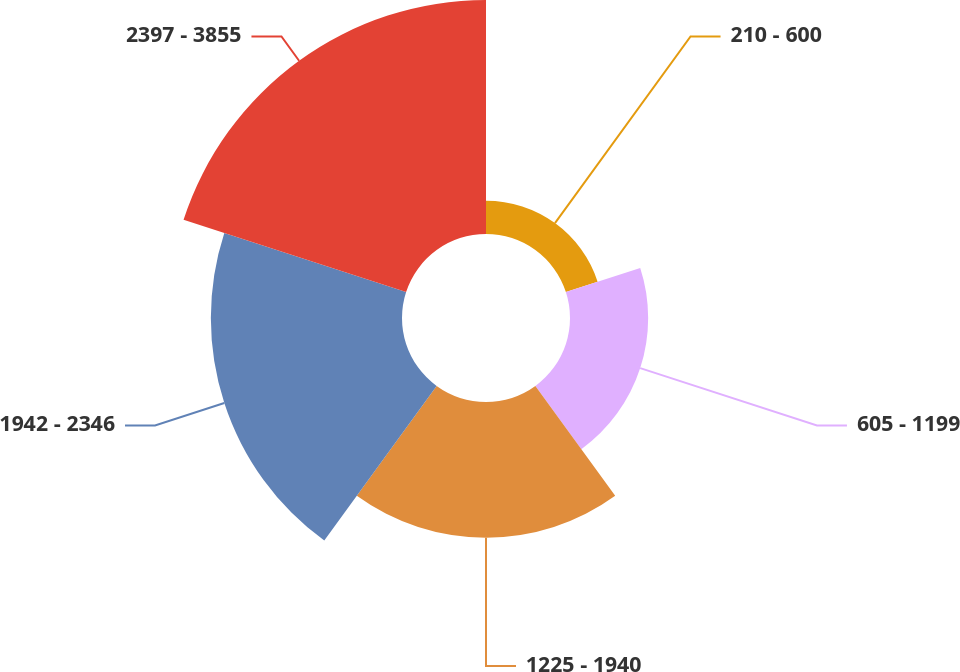<chart> <loc_0><loc_0><loc_500><loc_500><pie_chart><fcel>210 - 600<fcel>605 - 1199<fcel>1225 - 1940<fcel>1942 - 2346<fcel>2397 - 3855<nl><fcel>4.96%<fcel>11.62%<fcel>20.19%<fcel>28.42%<fcel>34.79%<nl></chart> 